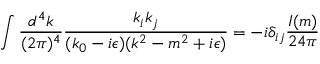Convert formula to latex. <formula><loc_0><loc_0><loc_500><loc_500>\int { \frac { d ^ { 4 } k } { ( 2 \pi ) ^ { 4 } } } { \frac { k _ { i } k _ { j } } { ( k _ { 0 } - i \epsilon ) ( k ^ { 2 } - m ^ { 2 } + i \epsilon ) } } = - i \delta _ { i j } { \frac { I ( m ) } { 2 4 \pi } }</formula> 